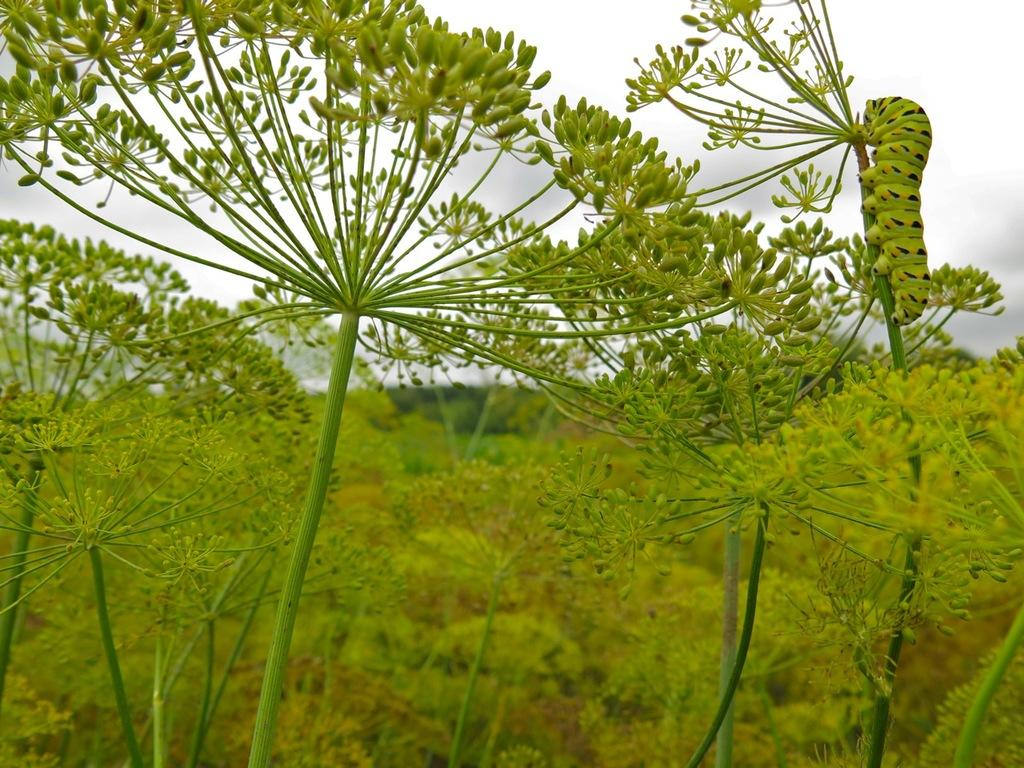What type of living organisms can be seen in the image? Plants are visible in the image. Are there any other creatures present on the plants? Yes, there is a green and black color insect on the plants. What can be seen in the background of the image? The sky is visible in the background of the image. Can you see any fairies flying around the plants in the image? No, there are no fairies present in the image. Is there a train visible in the background of the image? No, there is no train present in the image; only the sky is visible in the background. 